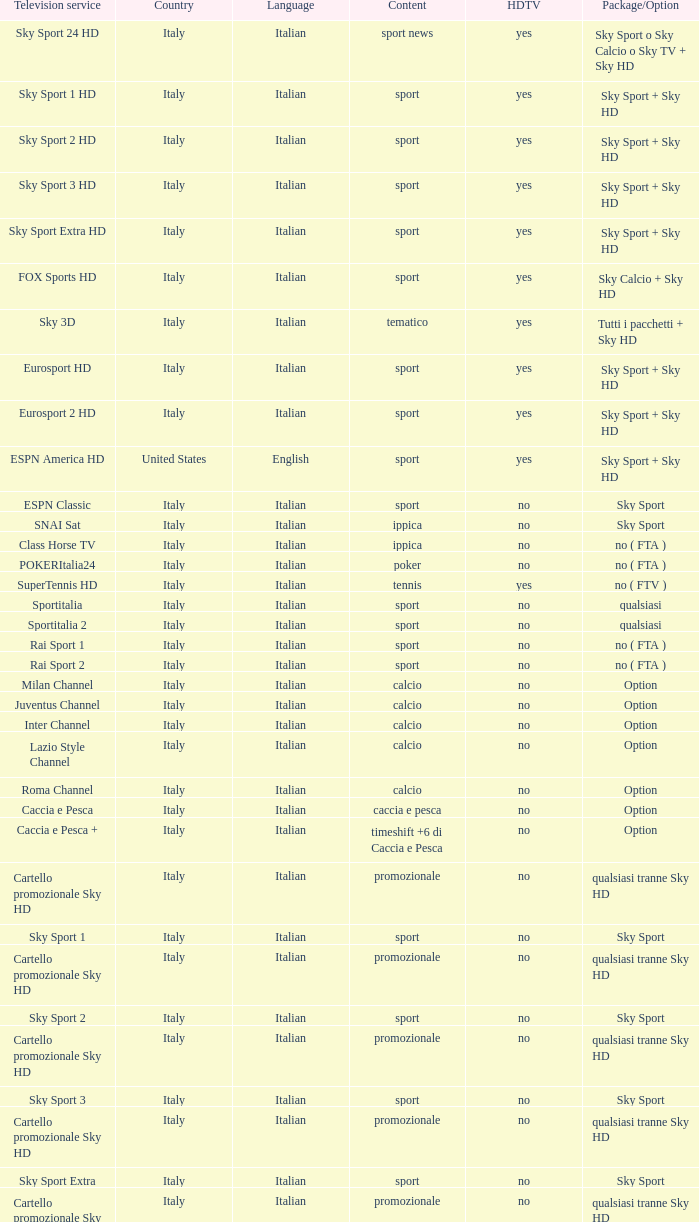What is tv subscription when the content is calcio, and when the package/variant is option? Milan Channel, Juventus Channel, Inter Channel, Lazio Style Channel, Roma Channel. 